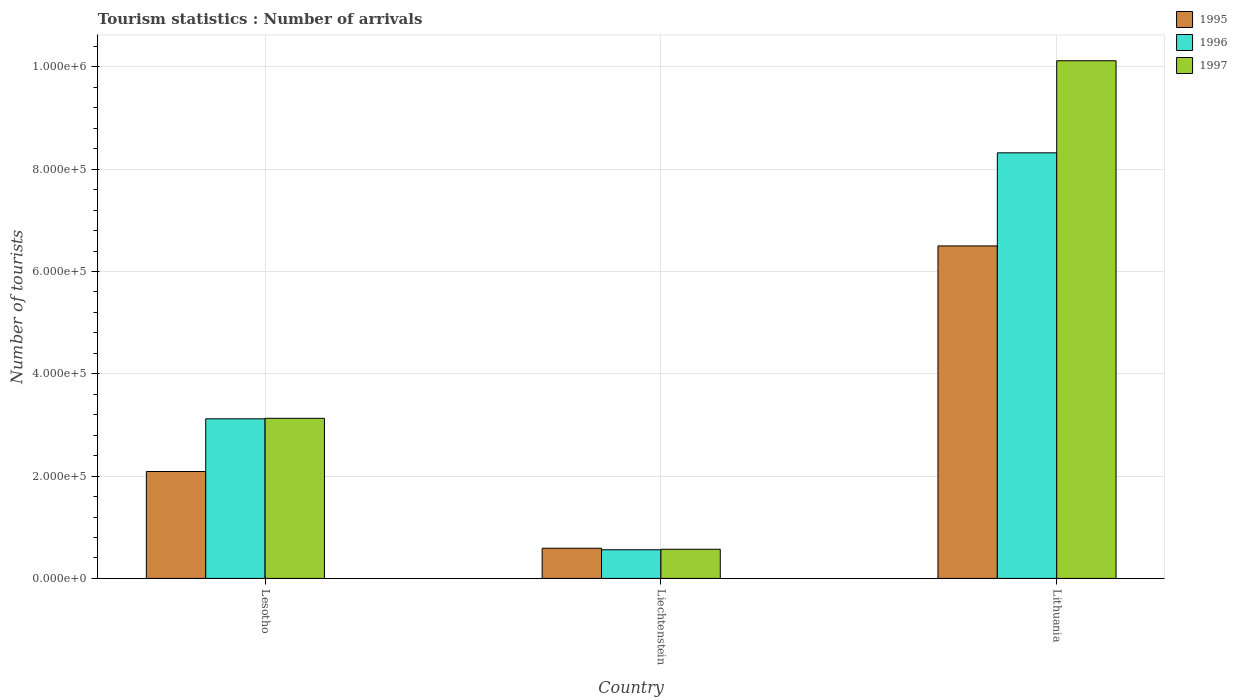How many different coloured bars are there?
Keep it short and to the point. 3. Are the number of bars per tick equal to the number of legend labels?
Give a very brief answer. Yes. How many bars are there on the 2nd tick from the right?
Keep it short and to the point. 3. What is the label of the 1st group of bars from the left?
Keep it short and to the point. Lesotho. In how many cases, is the number of bars for a given country not equal to the number of legend labels?
Ensure brevity in your answer.  0. What is the number of tourist arrivals in 1995 in Lithuania?
Ensure brevity in your answer.  6.50e+05. Across all countries, what is the maximum number of tourist arrivals in 1997?
Provide a succinct answer. 1.01e+06. Across all countries, what is the minimum number of tourist arrivals in 1995?
Make the answer very short. 5.90e+04. In which country was the number of tourist arrivals in 1997 maximum?
Make the answer very short. Lithuania. In which country was the number of tourist arrivals in 1996 minimum?
Provide a short and direct response. Liechtenstein. What is the total number of tourist arrivals in 1997 in the graph?
Offer a very short reply. 1.38e+06. What is the difference between the number of tourist arrivals in 1997 in Lesotho and that in Liechtenstein?
Your answer should be compact. 2.56e+05. What is the difference between the number of tourist arrivals in 1997 in Lesotho and the number of tourist arrivals in 1995 in Lithuania?
Make the answer very short. -3.37e+05. What is the difference between the number of tourist arrivals of/in 1996 and number of tourist arrivals of/in 1997 in Liechtenstein?
Provide a short and direct response. -1000. What is the ratio of the number of tourist arrivals in 1995 in Liechtenstein to that in Lithuania?
Your answer should be very brief. 0.09. Is the difference between the number of tourist arrivals in 1996 in Lesotho and Liechtenstein greater than the difference between the number of tourist arrivals in 1997 in Lesotho and Liechtenstein?
Give a very brief answer. No. What is the difference between the highest and the second highest number of tourist arrivals in 1997?
Your answer should be compact. 9.55e+05. What is the difference between the highest and the lowest number of tourist arrivals in 1995?
Provide a succinct answer. 5.91e+05. In how many countries, is the number of tourist arrivals in 1996 greater than the average number of tourist arrivals in 1996 taken over all countries?
Keep it short and to the point. 1. What does the 3rd bar from the left in Lithuania represents?
Offer a terse response. 1997. What does the 3rd bar from the right in Lesotho represents?
Offer a terse response. 1995. Is it the case that in every country, the sum of the number of tourist arrivals in 1996 and number of tourist arrivals in 1995 is greater than the number of tourist arrivals in 1997?
Provide a short and direct response. Yes. How many bars are there?
Keep it short and to the point. 9. Are all the bars in the graph horizontal?
Offer a terse response. No. How many countries are there in the graph?
Provide a succinct answer. 3. What is the difference between two consecutive major ticks on the Y-axis?
Your response must be concise. 2.00e+05. Are the values on the major ticks of Y-axis written in scientific E-notation?
Offer a very short reply. Yes. Does the graph contain any zero values?
Offer a terse response. No. Does the graph contain grids?
Your answer should be compact. Yes. How are the legend labels stacked?
Provide a succinct answer. Vertical. What is the title of the graph?
Your answer should be compact. Tourism statistics : Number of arrivals. Does "1964" appear as one of the legend labels in the graph?
Make the answer very short. No. What is the label or title of the Y-axis?
Give a very brief answer. Number of tourists. What is the Number of tourists in 1995 in Lesotho?
Ensure brevity in your answer.  2.09e+05. What is the Number of tourists in 1996 in Lesotho?
Offer a terse response. 3.12e+05. What is the Number of tourists of 1997 in Lesotho?
Your response must be concise. 3.13e+05. What is the Number of tourists in 1995 in Liechtenstein?
Offer a terse response. 5.90e+04. What is the Number of tourists of 1996 in Liechtenstein?
Provide a short and direct response. 5.60e+04. What is the Number of tourists of 1997 in Liechtenstein?
Ensure brevity in your answer.  5.70e+04. What is the Number of tourists of 1995 in Lithuania?
Give a very brief answer. 6.50e+05. What is the Number of tourists in 1996 in Lithuania?
Offer a very short reply. 8.32e+05. What is the Number of tourists of 1997 in Lithuania?
Provide a succinct answer. 1.01e+06. Across all countries, what is the maximum Number of tourists of 1995?
Offer a very short reply. 6.50e+05. Across all countries, what is the maximum Number of tourists in 1996?
Offer a terse response. 8.32e+05. Across all countries, what is the maximum Number of tourists in 1997?
Provide a succinct answer. 1.01e+06. Across all countries, what is the minimum Number of tourists in 1995?
Make the answer very short. 5.90e+04. Across all countries, what is the minimum Number of tourists of 1996?
Your answer should be compact. 5.60e+04. Across all countries, what is the minimum Number of tourists in 1997?
Make the answer very short. 5.70e+04. What is the total Number of tourists in 1995 in the graph?
Your answer should be very brief. 9.18e+05. What is the total Number of tourists in 1996 in the graph?
Offer a terse response. 1.20e+06. What is the total Number of tourists in 1997 in the graph?
Provide a short and direct response. 1.38e+06. What is the difference between the Number of tourists of 1995 in Lesotho and that in Liechtenstein?
Keep it short and to the point. 1.50e+05. What is the difference between the Number of tourists in 1996 in Lesotho and that in Liechtenstein?
Offer a terse response. 2.56e+05. What is the difference between the Number of tourists of 1997 in Lesotho and that in Liechtenstein?
Your answer should be very brief. 2.56e+05. What is the difference between the Number of tourists of 1995 in Lesotho and that in Lithuania?
Your answer should be compact. -4.41e+05. What is the difference between the Number of tourists in 1996 in Lesotho and that in Lithuania?
Provide a short and direct response. -5.20e+05. What is the difference between the Number of tourists of 1997 in Lesotho and that in Lithuania?
Give a very brief answer. -6.99e+05. What is the difference between the Number of tourists in 1995 in Liechtenstein and that in Lithuania?
Your answer should be very brief. -5.91e+05. What is the difference between the Number of tourists in 1996 in Liechtenstein and that in Lithuania?
Your response must be concise. -7.76e+05. What is the difference between the Number of tourists in 1997 in Liechtenstein and that in Lithuania?
Provide a short and direct response. -9.55e+05. What is the difference between the Number of tourists of 1995 in Lesotho and the Number of tourists of 1996 in Liechtenstein?
Give a very brief answer. 1.53e+05. What is the difference between the Number of tourists in 1995 in Lesotho and the Number of tourists in 1997 in Liechtenstein?
Your answer should be very brief. 1.52e+05. What is the difference between the Number of tourists in 1996 in Lesotho and the Number of tourists in 1997 in Liechtenstein?
Offer a very short reply. 2.55e+05. What is the difference between the Number of tourists of 1995 in Lesotho and the Number of tourists of 1996 in Lithuania?
Offer a terse response. -6.23e+05. What is the difference between the Number of tourists in 1995 in Lesotho and the Number of tourists in 1997 in Lithuania?
Give a very brief answer. -8.03e+05. What is the difference between the Number of tourists of 1996 in Lesotho and the Number of tourists of 1997 in Lithuania?
Provide a succinct answer. -7.00e+05. What is the difference between the Number of tourists in 1995 in Liechtenstein and the Number of tourists in 1996 in Lithuania?
Your response must be concise. -7.73e+05. What is the difference between the Number of tourists of 1995 in Liechtenstein and the Number of tourists of 1997 in Lithuania?
Your answer should be very brief. -9.53e+05. What is the difference between the Number of tourists in 1996 in Liechtenstein and the Number of tourists in 1997 in Lithuania?
Your answer should be compact. -9.56e+05. What is the average Number of tourists in 1995 per country?
Your answer should be very brief. 3.06e+05. What is the average Number of tourists of 1996 per country?
Keep it short and to the point. 4.00e+05. What is the average Number of tourists in 1997 per country?
Your answer should be very brief. 4.61e+05. What is the difference between the Number of tourists of 1995 and Number of tourists of 1996 in Lesotho?
Your response must be concise. -1.03e+05. What is the difference between the Number of tourists in 1995 and Number of tourists in 1997 in Lesotho?
Offer a terse response. -1.04e+05. What is the difference between the Number of tourists of 1996 and Number of tourists of 1997 in Lesotho?
Your answer should be compact. -1000. What is the difference between the Number of tourists in 1995 and Number of tourists in 1996 in Liechtenstein?
Your response must be concise. 3000. What is the difference between the Number of tourists of 1996 and Number of tourists of 1997 in Liechtenstein?
Keep it short and to the point. -1000. What is the difference between the Number of tourists in 1995 and Number of tourists in 1996 in Lithuania?
Provide a short and direct response. -1.82e+05. What is the difference between the Number of tourists in 1995 and Number of tourists in 1997 in Lithuania?
Provide a short and direct response. -3.62e+05. What is the ratio of the Number of tourists in 1995 in Lesotho to that in Liechtenstein?
Offer a terse response. 3.54. What is the ratio of the Number of tourists in 1996 in Lesotho to that in Liechtenstein?
Keep it short and to the point. 5.57. What is the ratio of the Number of tourists in 1997 in Lesotho to that in Liechtenstein?
Give a very brief answer. 5.49. What is the ratio of the Number of tourists in 1995 in Lesotho to that in Lithuania?
Make the answer very short. 0.32. What is the ratio of the Number of tourists in 1997 in Lesotho to that in Lithuania?
Provide a succinct answer. 0.31. What is the ratio of the Number of tourists of 1995 in Liechtenstein to that in Lithuania?
Make the answer very short. 0.09. What is the ratio of the Number of tourists in 1996 in Liechtenstein to that in Lithuania?
Your answer should be very brief. 0.07. What is the ratio of the Number of tourists of 1997 in Liechtenstein to that in Lithuania?
Provide a succinct answer. 0.06. What is the difference between the highest and the second highest Number of tourists in 1995?
Your answer should be very brief. 4.41e+05. What is the difference between the highest and the second highest Number of tourists of 1996?
Your answer should be very brief. 5.20e+05. What is the difference between the highest and the second highest Number of tourists in 1997?
Your answer should be compact. 6.99e+05. What is the difference between the highest and the lowest Number of tourists of 1995?
Give a very brief answer. 5.91e+05. What is the difference between the highest and the lowest Number of tourists of 1996?
Provide a short and direct response. 7.76e+05. What is the difference between the highest and the lowest Number of tourists of 1997?
Provide a short and direct response. 9.55e+05. 